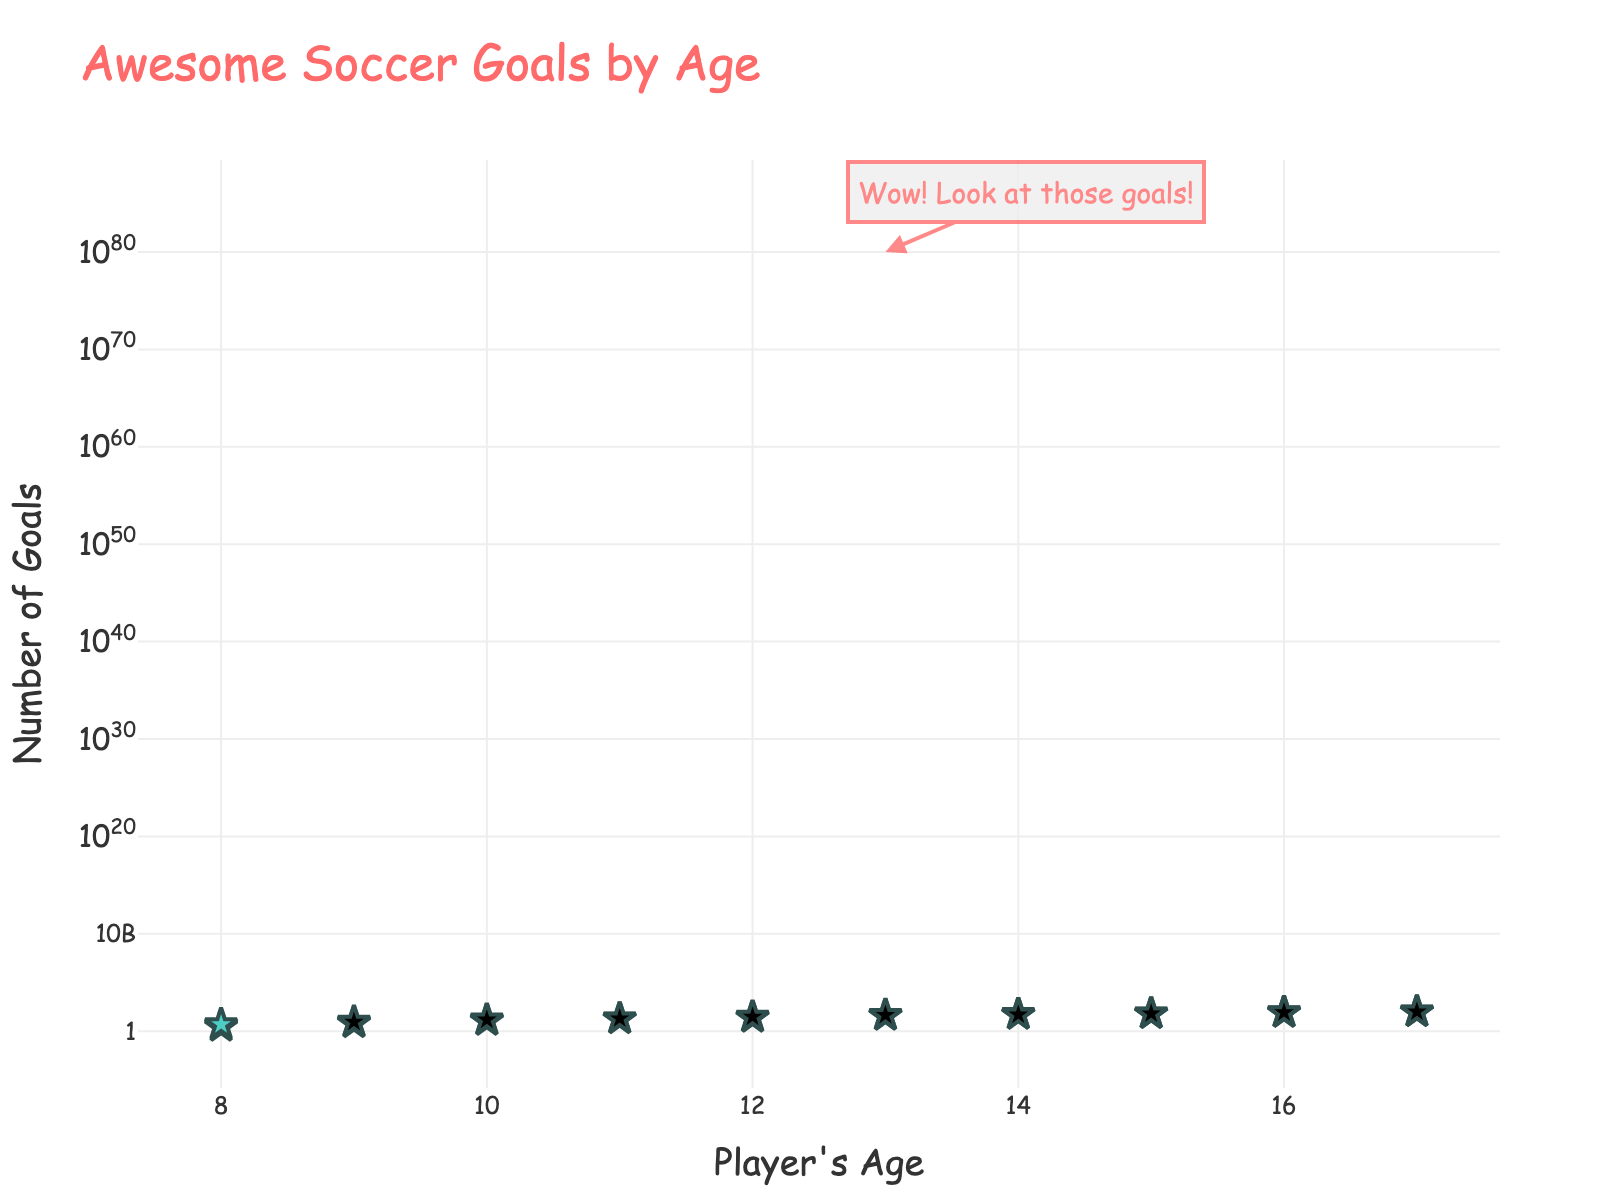What's the title of the plot? The title is displayed at the top of the plot and it reflects the overall focus or subject of the data presented.
Answer: Awesome Soccer Goals by Age What does the y-axis represent? The y-axis label indicates what type of data is being plotted along that axis. In this case, it's labeled "Number of Goals," representing how many goals the players scored.
Answer: Number of Goals How many data points are there in the plot? By counting the number of individual markers (stars) on the scatter plot, we determine the total amount of data points presented.
Answer: 20 What is the color scheme used for the markers? Observing the color of the markers used in the scatter plot, it's evident that two distinct colors are used: one for goals at certain ages and another for the other ages.
Answer: #FF6B6B and #4ECDC4 What is the highest number of goals scored and at what age? The highest point on the y-axis indicates the maximum number of goals scored, and its corresponding x-axis value gives the age.
Answer: 100 goals at age 17 Between the ages of 9 and 12, how many goals did players score at most? Observing the points corresponding to ages 9, 10, 11, and 12, find the highest y-value among these points.
Answer: 30 goals at age 12 Is there a general trend in the data as the players get older? By examining the overall direction and pattern of the points, one can infer whether there's an upward, downward, or no apparent trend. The y-values appear to increase as the x-values (age) increase.
Answer: Goals increase with age Compare the number of goals scored by 13-year-olds and 14-year-olds. Who scores more on average? Calculate the average goals scored for age 13 and for age 14, then compare these averages. 
Age 13: (40 + 45) / 2 = 42.5
Age 14: (55 + 50) / 2 = 52.5
Answer: 14-year-olds What is the median number of goals scored across all data points? Arrange the 20 goal values in ascending order and find the middle value. Since there is an even number of data points, the median is the average of the 10th and 11th values. 
Sort the values: 3, 5, 7, 9, 12, 15, 18, 20, 25, 30, 40, 45, 50, 55, 60, 65, 80, 85, 95, 100 
Median: (30 + 40) / 2 = 35
Answer: 35 Are there any annotations on the plot? If yes, what do they indicate? Annotations are often added to highlight significant data or insights; this annotation is added near a specific point with text and an arrow emphasizing a notable trend or value.
Answer: Yes, emphasizing the high number of goals at age 13 